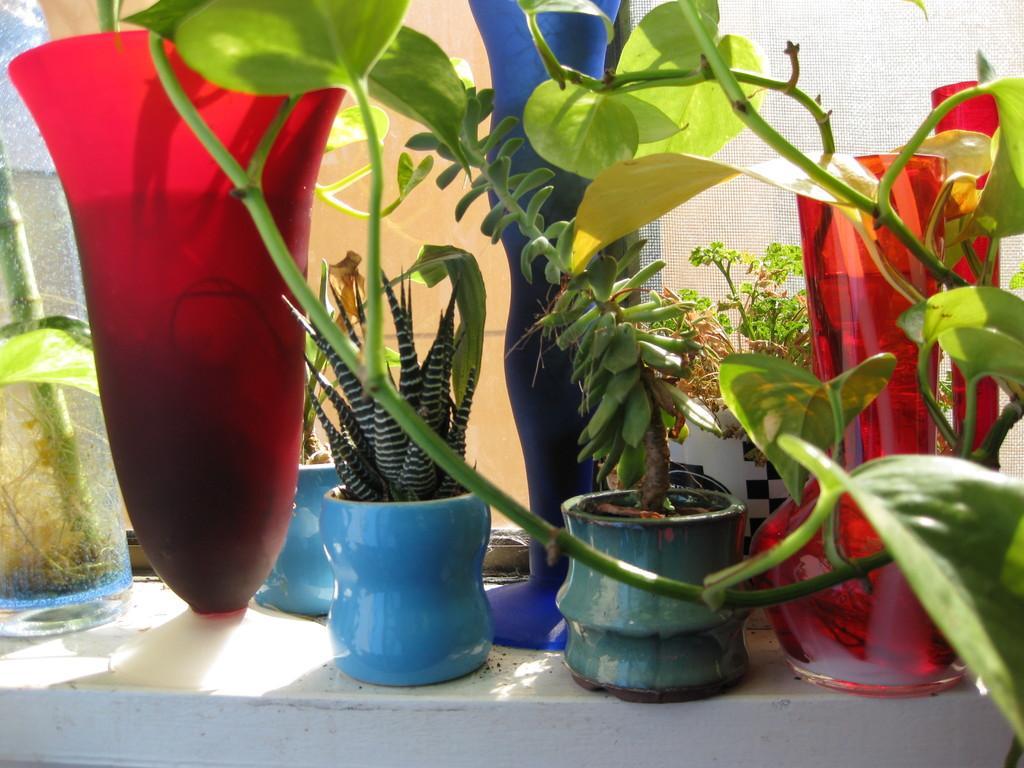How would you summarize this image in a sentence or two? In the picture I can see plant pots on a white color surface. In the background I can see a net and some other objects. 